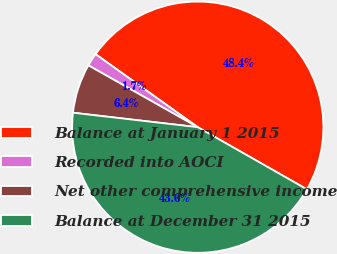Convert chart. <chart><loc_0><loc_0><loc_500><loc_500><pie_chart><fcel>Balance at January 1 2015<fcel>Recorded into AOCI<fcel>Net other comprehensive income<fcel>Balance at December 31 2015<nl><fcel>48.36%<fcel>1.69%<fcel>6.35%<fcel>43.6%<nl></chart> 